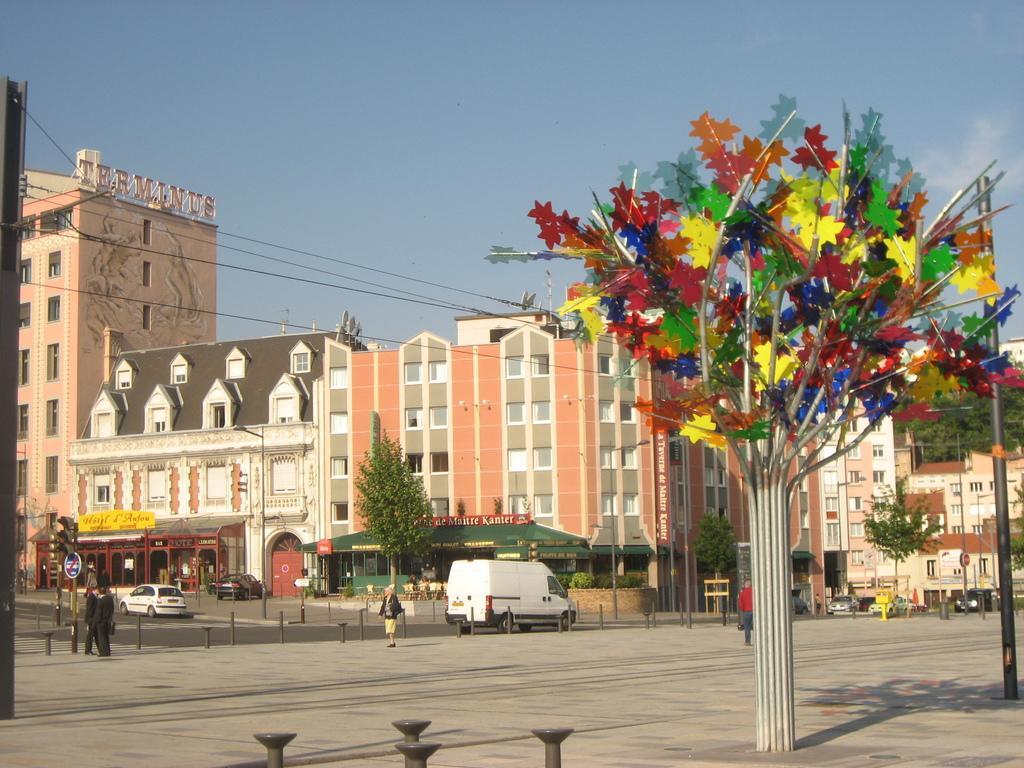How would you summarize this image in a sentence or two? In this image there are a few people walking on the pavement and there are metal rods, sign boards, lamp posts and some structures on the pavement, in front of the pavement on the road there are some vehicles, beside the road there are trees and buildings, on the buildings there are name boards, at the top of the image there are cables. 